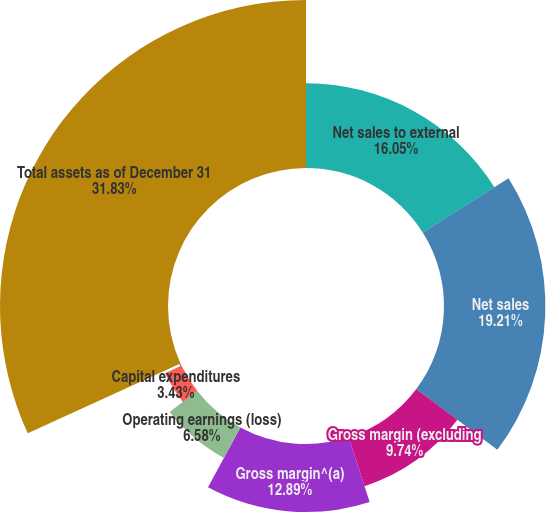Convert chart. <chart><loc_0><loc_0><loc_500><loc_500><pie_chart><fcel>Net sales to external<fcel>Net sales<fcel>Gross margin (excluding<fcel>Gross margin^(a)<fcel>Operating earnings (loss)<fcel>Capital expenditures<fcel>Depreciation depletion and<fcel>Total assets as of December 31<nl><fcel>16.05%<fcel>19.21%<fcel>9.74%<fcel>12.89%<fcel>6.58%<fcel>3.43%<fcel>0.27%<fcel>31.83%<nl></chart> 